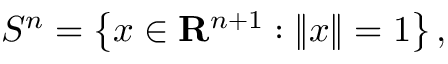<formula> <loc_0><loc_0><loc_500><loc_500>S ^ { n } = \left \{ x \in R ^ { n + 1 } \colon \left \| x \right \| = 1 \right \} ,</formula> 